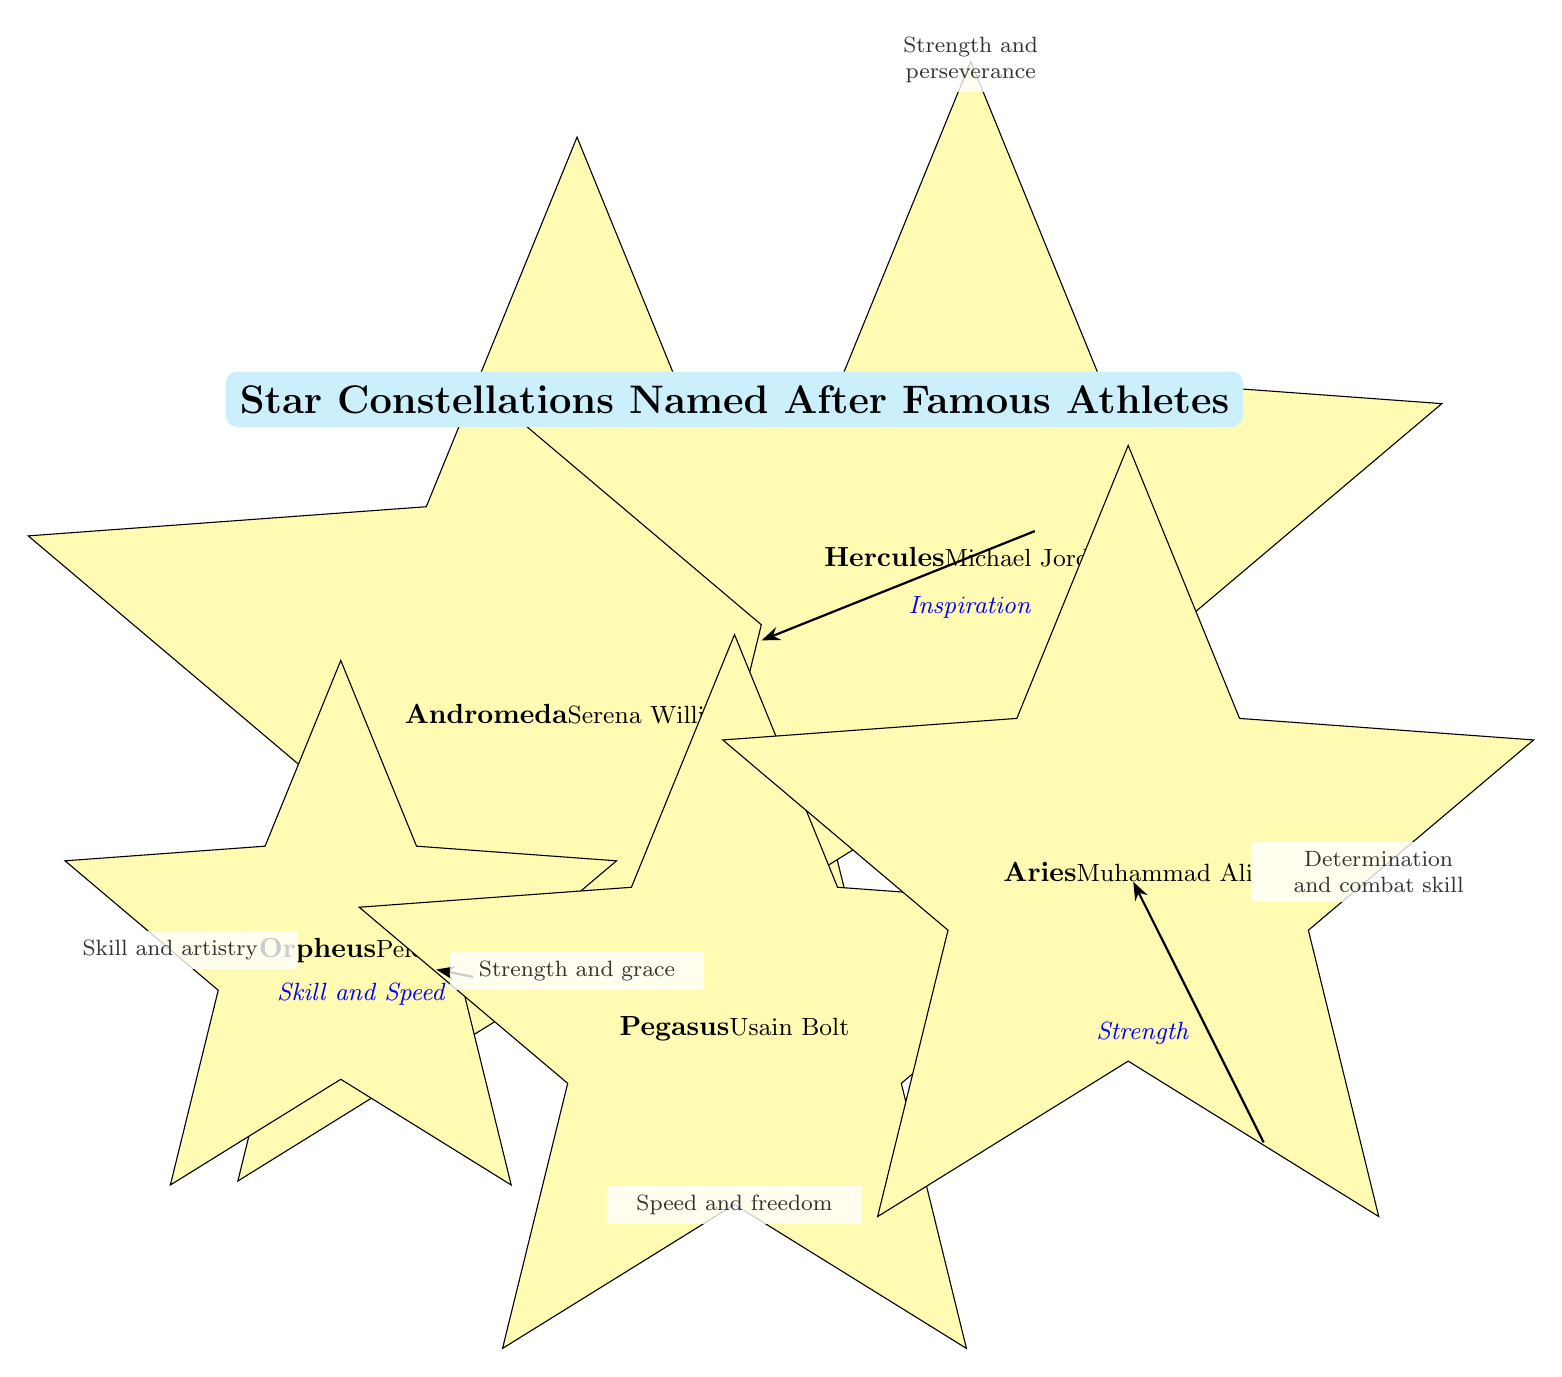What is the name of the constellation associated with Serena Williams? The node for Andromeda states "Serena Williams" as the athlete associated with that constellation.
Answer: Andromeda How many constellations are listed in the diagram? There are five nodes representing constellations, which indicates a total of five constellations in the diagram.
Answer: 5 Which athlete is linked to the concept of "Inspiration"? The edge that connects Andromeda to Hercules is labeled "Inspiration," linking the athlete Serena Williams (Andromeda) to Michael Jordan (Hercules).
Answer: Michael Jordan What characteristic is described for Pegasus? The description positioned below Pegasus highlights "Speed and freedom," indicating the traits associated with Usain Bolt, the athlete linked to this constellation.
Answer: Speed and freedom Which constellation connects Skill and Speed to another constellation? The edge between Orpheus and Pegasus is labeled "Skill and Speed," signifying that these traits connect Orpheus to Pegasus.
Answer: Pegasus What is the descriptive phrase associated with Muhammad Ali's constellation? The phrase located to the right of the Aries constellation describes "Determination and combat skill," which pertains to Muhammad Ali.
Answer: Determination and combat skill Which constellation exhibits the theme of "Strength and grace"? The description beneath Andromeda states "Strength and grace," linking these characteristics with Serena Williams, who corresponds to this constellation.
Answer: Andromeda What are the connections between Hercules and other constellations? Hercules is connected to Andromeda through "Inspiration" and to Aries through "Strength," indicating its role as a central figure in the diagram.
Answer: Andromeda, Aries Which athlete is represented by the constellation Orpheus? The label on the Orpheus node indicates that Pelé is the athlete represented by this constellation.
Answer: Pelé 